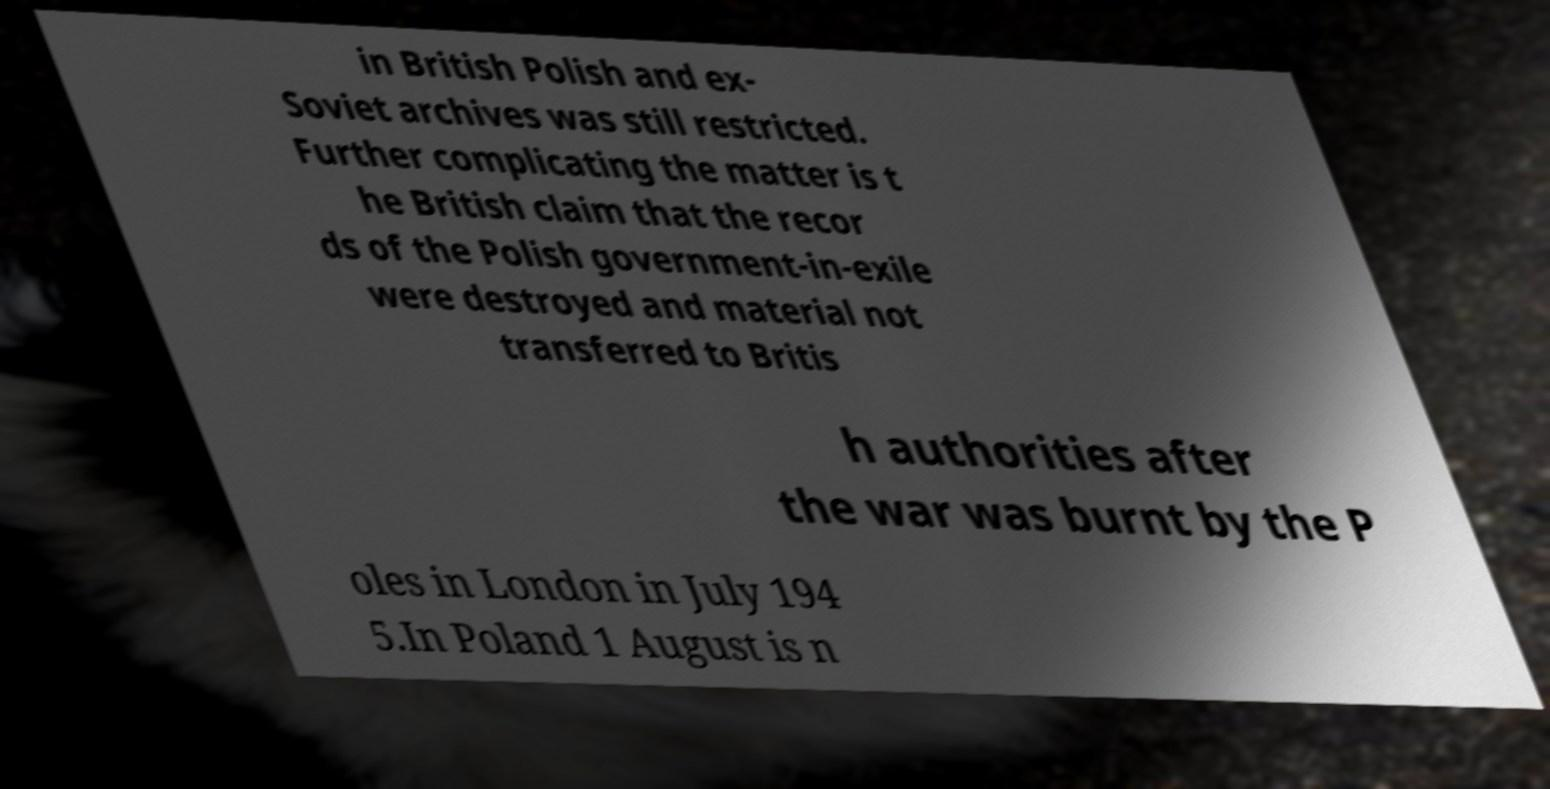For documentation purposes, I need the text within this image transcribed. Could you provide that? in British Polish and ex- Soviet archives was still restricted. Further complicating the matter is t he British claim that the recor ds of the Polish government-in-exile were destroyed and material not transferred to Britis h authorities after the war was burnt by the P oles in London in July 194 5.In Poland 1 August is n 